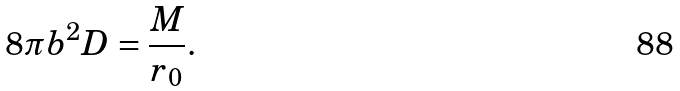Convert formula to latex. <formula><loc_0><loc_0><loc_500><loc_500>8 \pi b ^ { 2 } D = \frac { M } { r _ { 0 } } .</formula> 